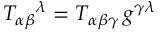Convert formula to latex. <formula><loc_0><loc_0><loc_500><loc_500>T _ { \alpha \beta ^ { \lambda } = T _ { \alpha \beta \gamma } \, g ^ { \gamma \lambda }</formula> 